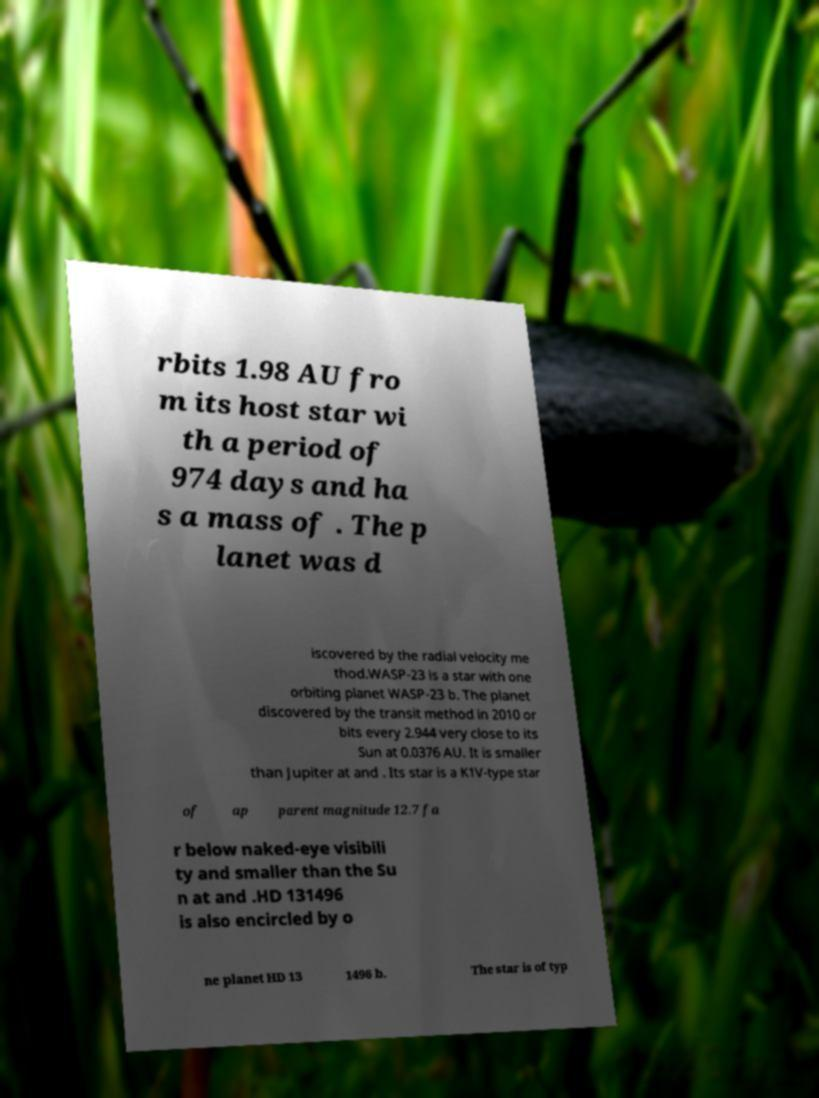Please identify and transcribe the text found in this image. rbits 1.98 AU fro m its host star wi th a period of 974 days and ha s a mass of . The p lanet was d iscovered by the radial velocity me thod.WASP-23 is a star with one orbiting planet WASP-23 b. The planet discovered by the transit method in 2010 or bits every 2.944 very close to its Sun at 0.0376 AU. It is smaller than Jupiter at and . Its star is a K1V-type star of ap parent magnitude 12.7 fa r below naked-eye visibili ty and smaller than the Su n at and .HD 131496 is also encircled by o ne planet HD 13 1496 b. The star is of typ 